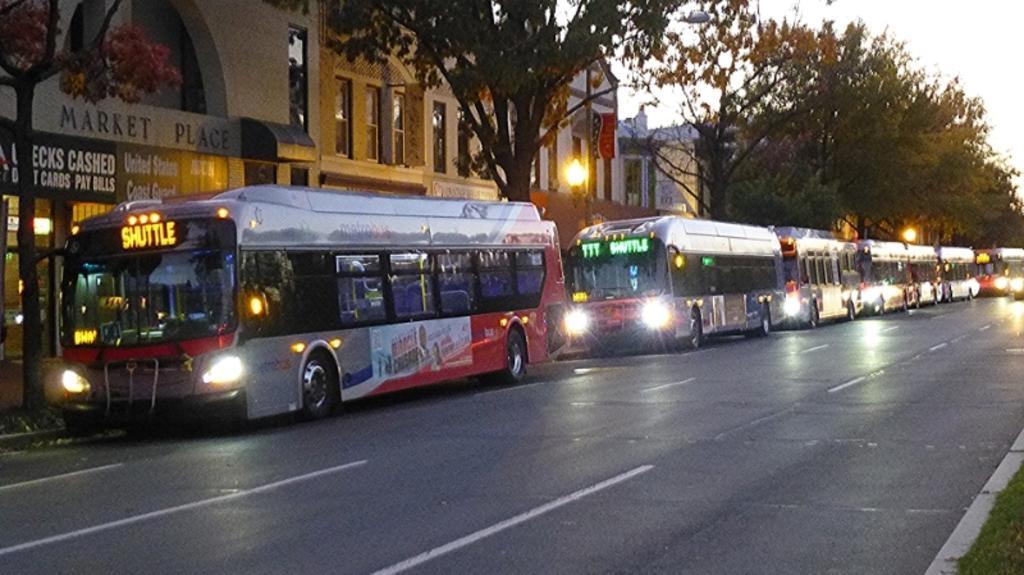How would you summarize this image in a sentence or two? In the image in the center we can see few buses on the road. In the background we can see sky,clouds,trees,buildings,wall,windows,banners,street lights,grass etc. 